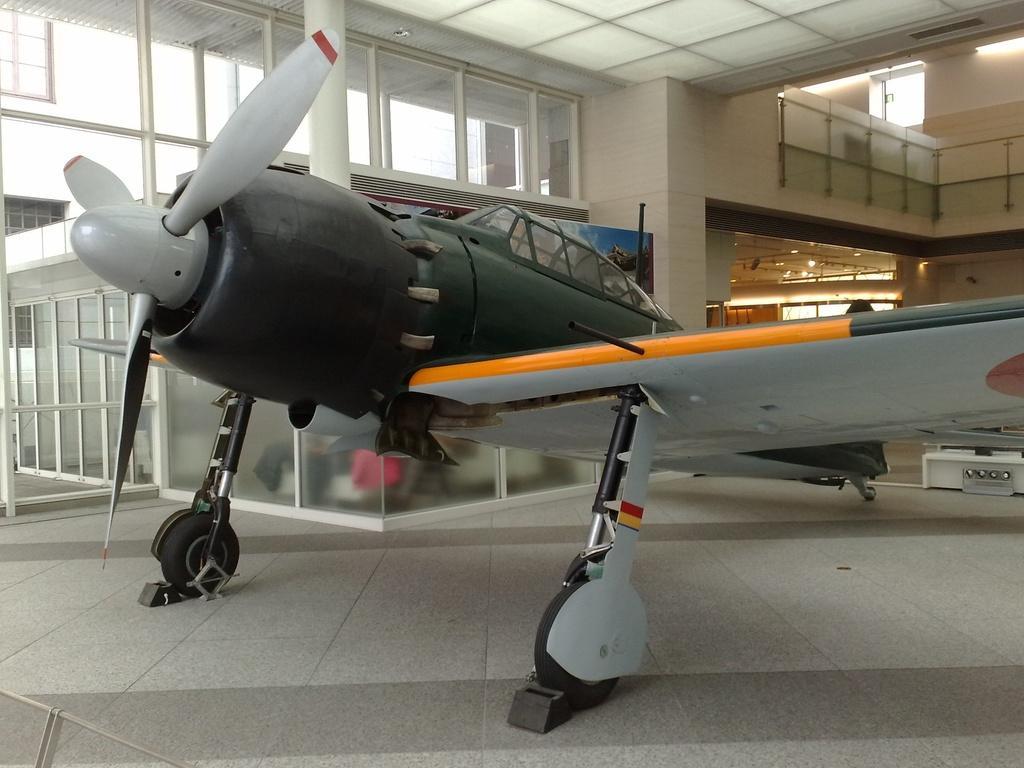In one or two sentences, can you explain what this image depicts? In the image there is a flight inside a compartment and behind the flight there are many windows. 